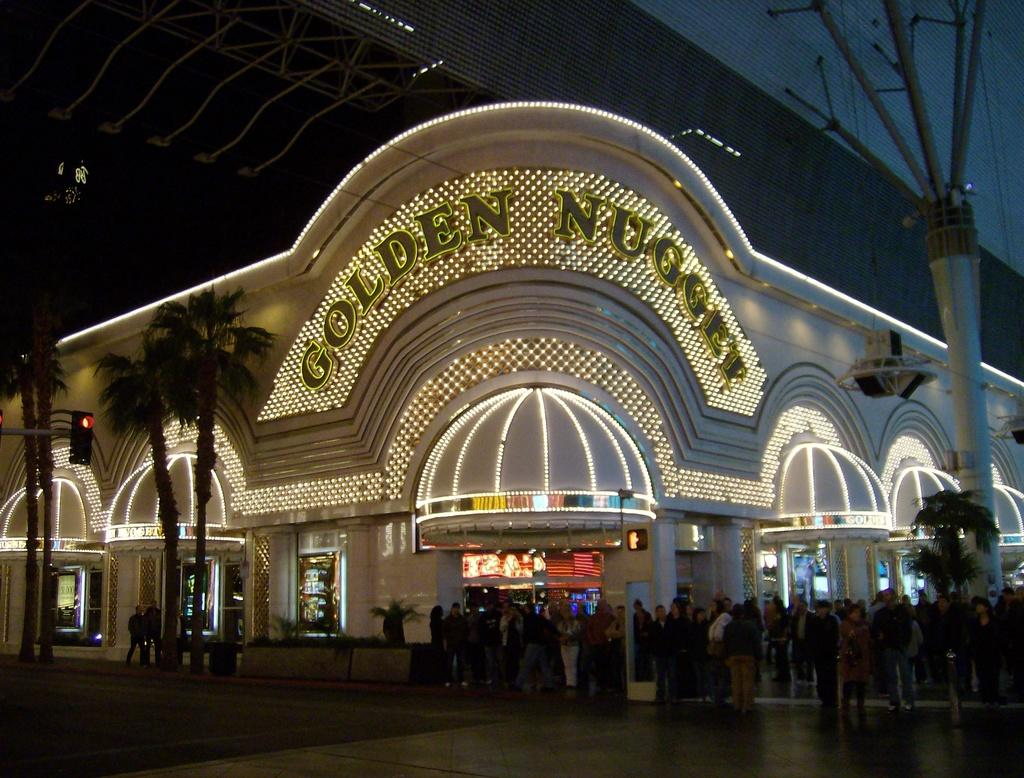How many people are in the image? There is a group of people in the image. What type of natural elements can be seen in the image? There are trees in the image. What type of structure is present in the image? There is a building with lights in the image. How many cats are drinking milk in the image? There are no cats or milk present in the image. 